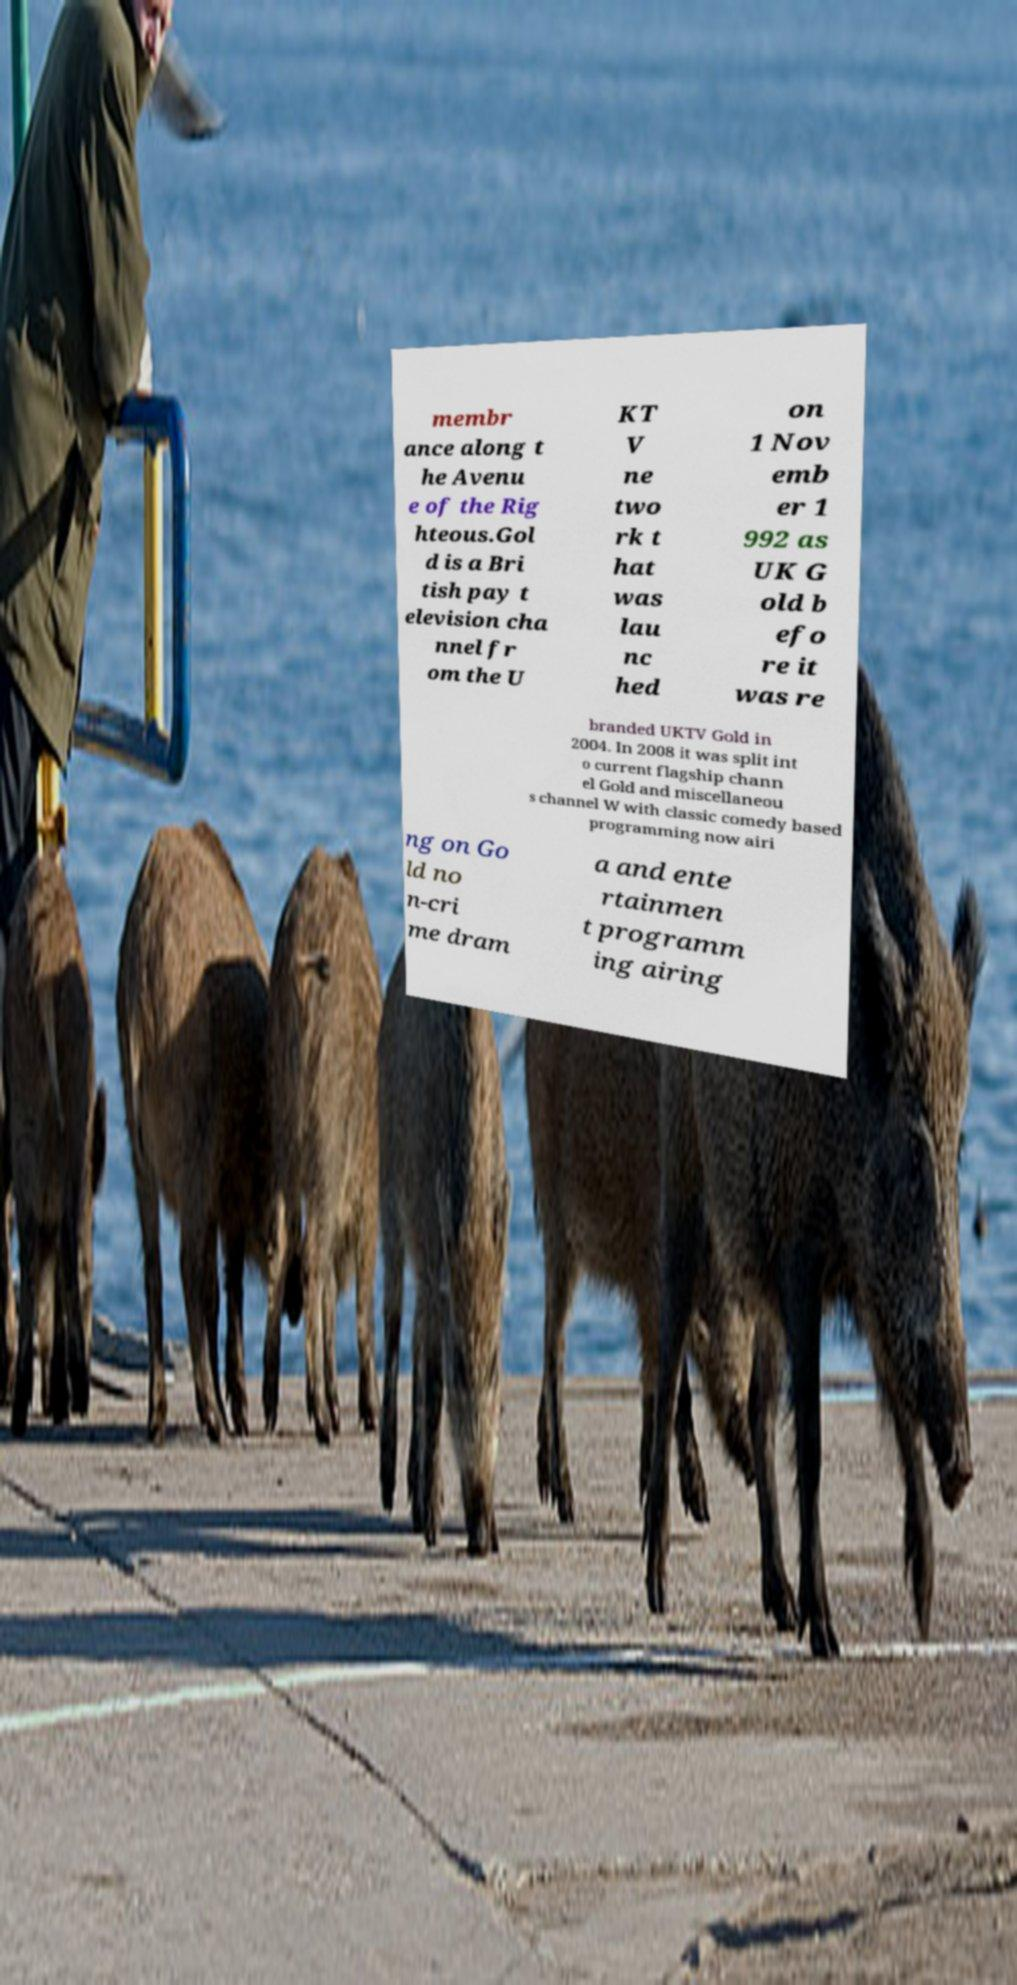Could you extract and type out the text from this image? membr ance along t he Avenu e of the Rig hteous.Gol d is a Bri tish pay t elevision cha nnel fr om the U KT V ne two rk t hat was lau nc hed on 1 Nov emb er 1 992 as UK G old b efo re it was re branded UKTV Gold in 2004. In 2008 it was split int o current flagship chann el Gold and miscellaneou s channel W with classic comedy based programming now airi ng on Go ld no n-cri me dram a and ente rtainmen t programm ing airing 